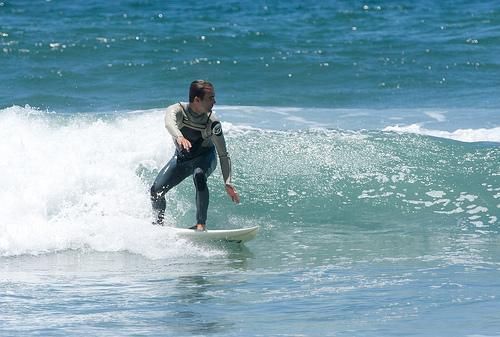How many people are in the picture?
Give a very brief answer. 1. 